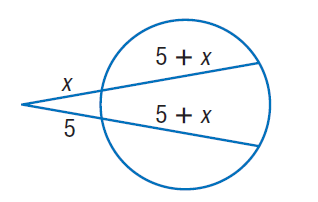Question: Find x. Round to the nearest tenth if necessary. Assume that segments that appear to be tangent are tangent.
Choices:
A. 5
B. 10
C. 15
D. 20
Answer with the letter. Answer: A 